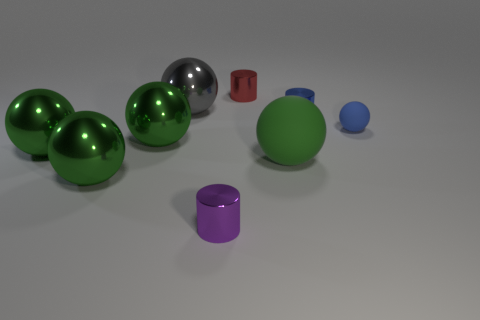Subtract all cyan cubes. How many green spheres are left? 4 Subtract all blue spheres. How many spheres are left? 5 Subtract 1 balls. How many balls are left? 5 Subtract all gray balls. How many balls are left? 5 Subtract all gray spheres. Subtract all cyan cylinders. How many spheres are left? 5 Subtract all balls. How many objects are left? 3 Subtract all tiny red shiny cylinders. Subtract all cylinders. How many objects are left? 5 Add 1 small red cylinders. How many small red cylinders are left? 2 Add 5 gray metal cylinders. How many gray metal cylinders exist? 5 Subtract 0 purple balls. How many objects are left? 9 